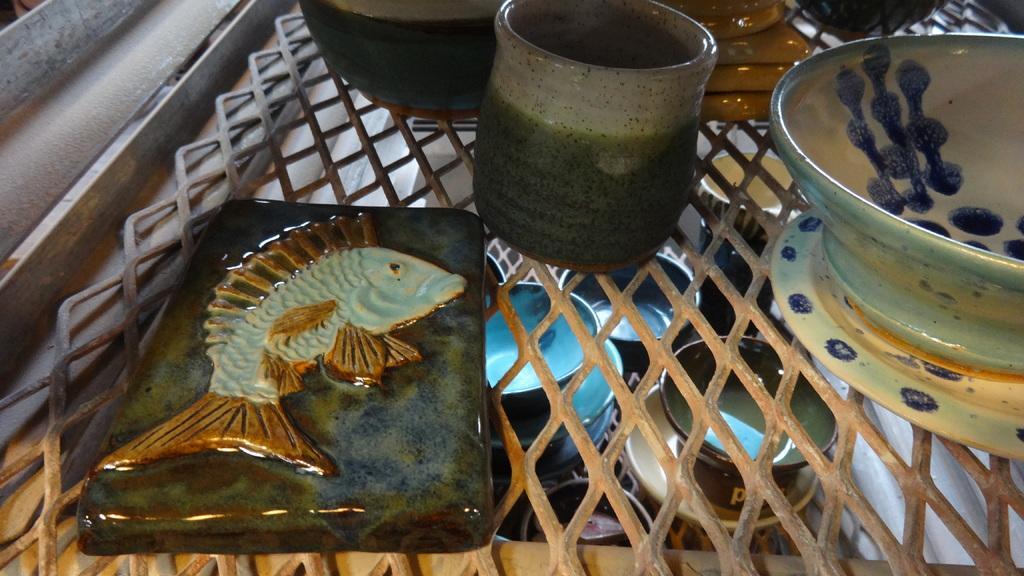Describe this image in one or two sentences. In this image there is a table on which there are ceramic bowls,cups and a bar on which there is a fish symbol. At the bottom there are cups one beside the other. 